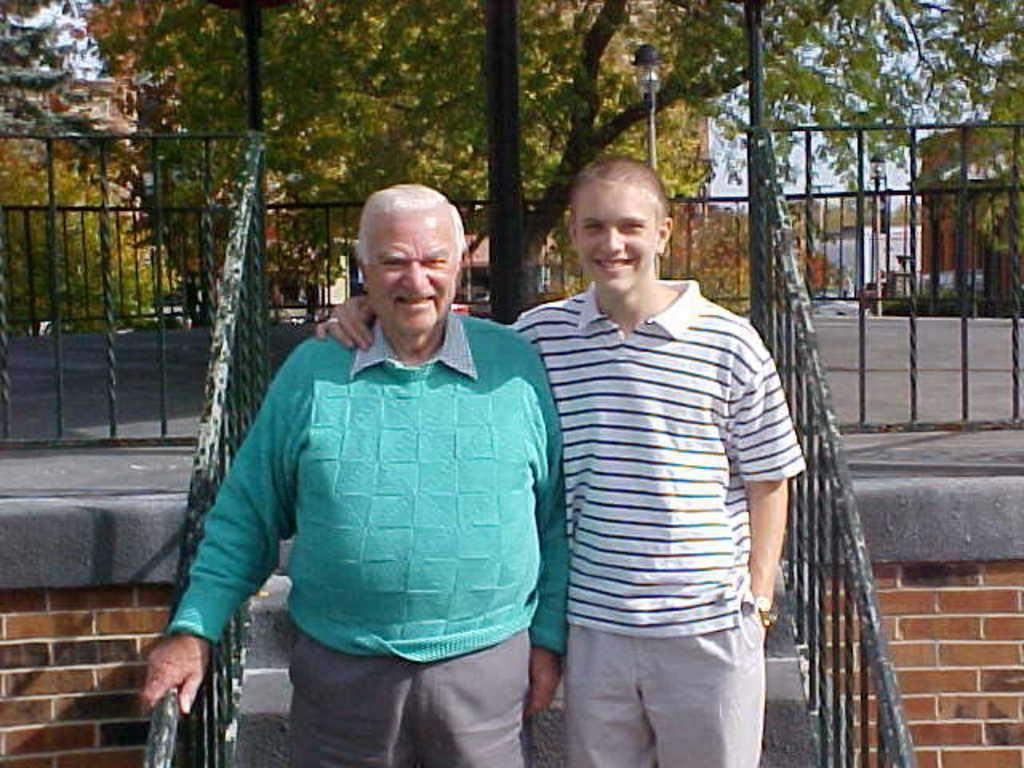How many people are present in the image? There are two people standing in the image. What is the facial expression of the people in the image? The people are smiling. What can be seen from left to right in the image? There is fencing from left to right in the image. What is visible in the background of the image? There are trees and buildings in the background of the image. What type of feather can be seen on the sweater of the person on the right in the image? There is no feather or sweater present on the person on the right in the image. What is the engine used for in the image? There is no engine present in the image. 